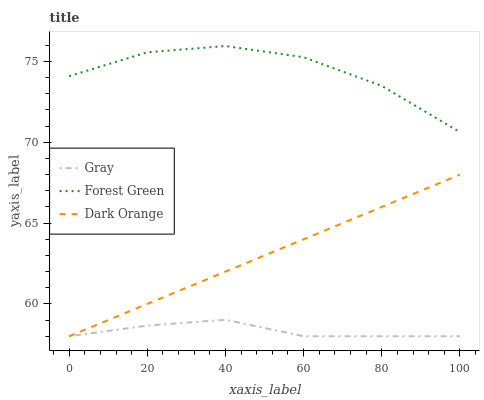Does Gray have the minimum area under the curve?
Answer yes or no. Yes. Does Forest Green have the maximum area under the curve?
Answer yes or no. Yes. Does Dark Orange have the minimum area under the curve?
Answer yes or no. No. Does Dark Orange have the maximum area under the curve?
Answer yes or no. No. Is Dark Orange the smoothest?
Answer yes or no. Yes. Is Forest Green the roughest?
Answer yes or no. Yes. Is Forest Green the smoothest?
Answer yes or no. No. Is Dark Orange the roughest?
Answer yes or no. No. Does Forest Green have the lowest value?
Answer yes or no. No. Does Forest Green have the highest value?
Answer yes or no. Yes. Does Dark Orange have the highest value?
Answer yes or no. No. Is Gray less than Forest Green?
Answer yes or no. Yes. Is Forest Green greater than Gray?
Answer yes or no. Yes. Does Dark Orange intersect Gray?
Answer yes or no. Yes. Is Dark Orange less than Gray?
Answer yes or no. No. Is Dark Orange greater than Gray?
Answer yes or no. No. Does Gray intersect Forest Green?
Answer yes or no. No. 